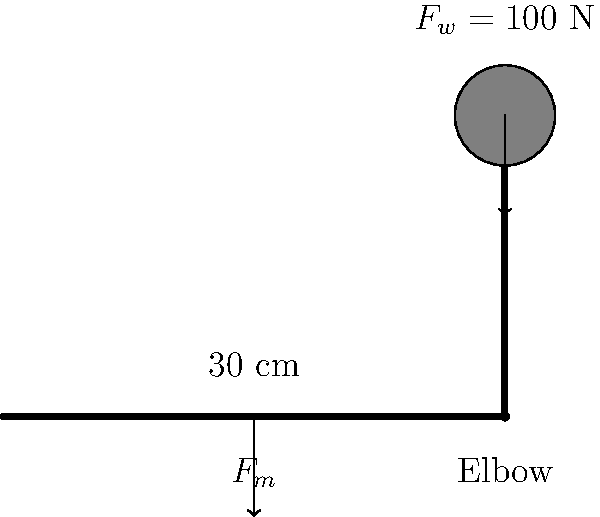As a librarian who appreciates organization and the digital transformation of data, consider the biomechanical analysis of a bicep curl. The free body diagram shows an arm holding a 10 kg weight. The distance from the elbow to the center of the weight is 30 cm. Calculate the torque generated at the elbow joint and the force required by the bicep muscle to hold this position, assuming the muscle attaches perpendicular to the forearm at a distance of 5 cm from the elbow. Let's approach this problem step-by-step, organizing our data and calculations:

1. Given data:
   - Weight mass = 10 kg
   - Distance from elbow to weight center = 30 cm = 0.3 m
   - Distance from elbow to bicep attachment = 5 cm = 0.05 m

2. Calculate the force of the weight ($F_w$):
   $F_w = m \cdot g = 10 \text{ kg} \cdot 9.8 \text{ m/s}^2 = 98 \text{ N}$

3. Calculate the torque ($\tau$) generated by the weight:
   $\tau = F_w \cdot d = 98 \text{ N} \cdot 0.3 \text{ m} = 29.4 \text{ N}\cdot\text{m}$

4. For equilibrium, the torque generated by the bicep muscle ($\tau_m$) must equal the torque generated by the weight:
   $\tau_m = \tau = 29.4 \text{ N}\cdot\text{m}$

5. Calculate the force required by the bicep muscle ($F_m$):
   $\tau_m = F_m \cdot d_m$
   $29.4 \text{ N}\cdot\text{m} = F_m \cdot 0.05 \text{ m}$
   $F_m = \frac{29.4 \text{ N}\cdot\text{m}}{0.05 \text{ m}} = 588 \text{ N}$

Thus, the torque generated at the elbow joint is 29.4 N·m, and the force required by the bicep muscle is 588 N.
Answer: Torque: 29.4 N·m, Bicep force: 588 N 